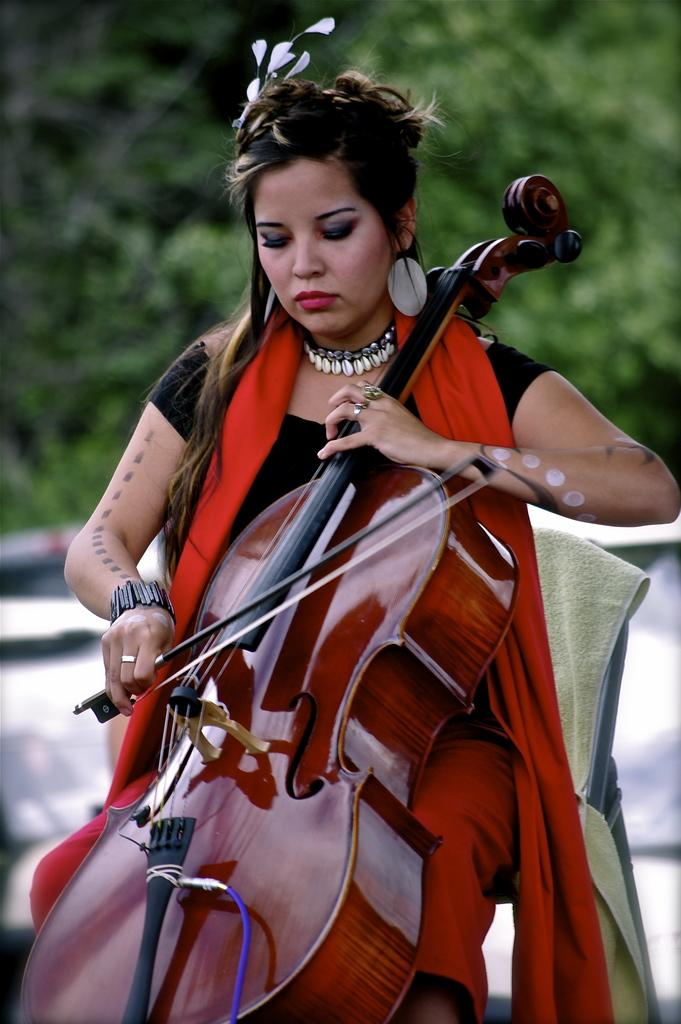Where was the image taken? The image was clicked outside. Who is present in the image? There is a woman in the image. What is the woman doing in the image? The woman is sitting in a chair and playing a violin. What is the woman wearing in the image? The woman is wearing a black and red dress. What can be seen in the background of the image? There are trees in the background of the image. What type of dog is sitting next to the woman in the image? There is no dog present in the image. What color is the flag flying in the background of the image? There is no flag present in the image. 